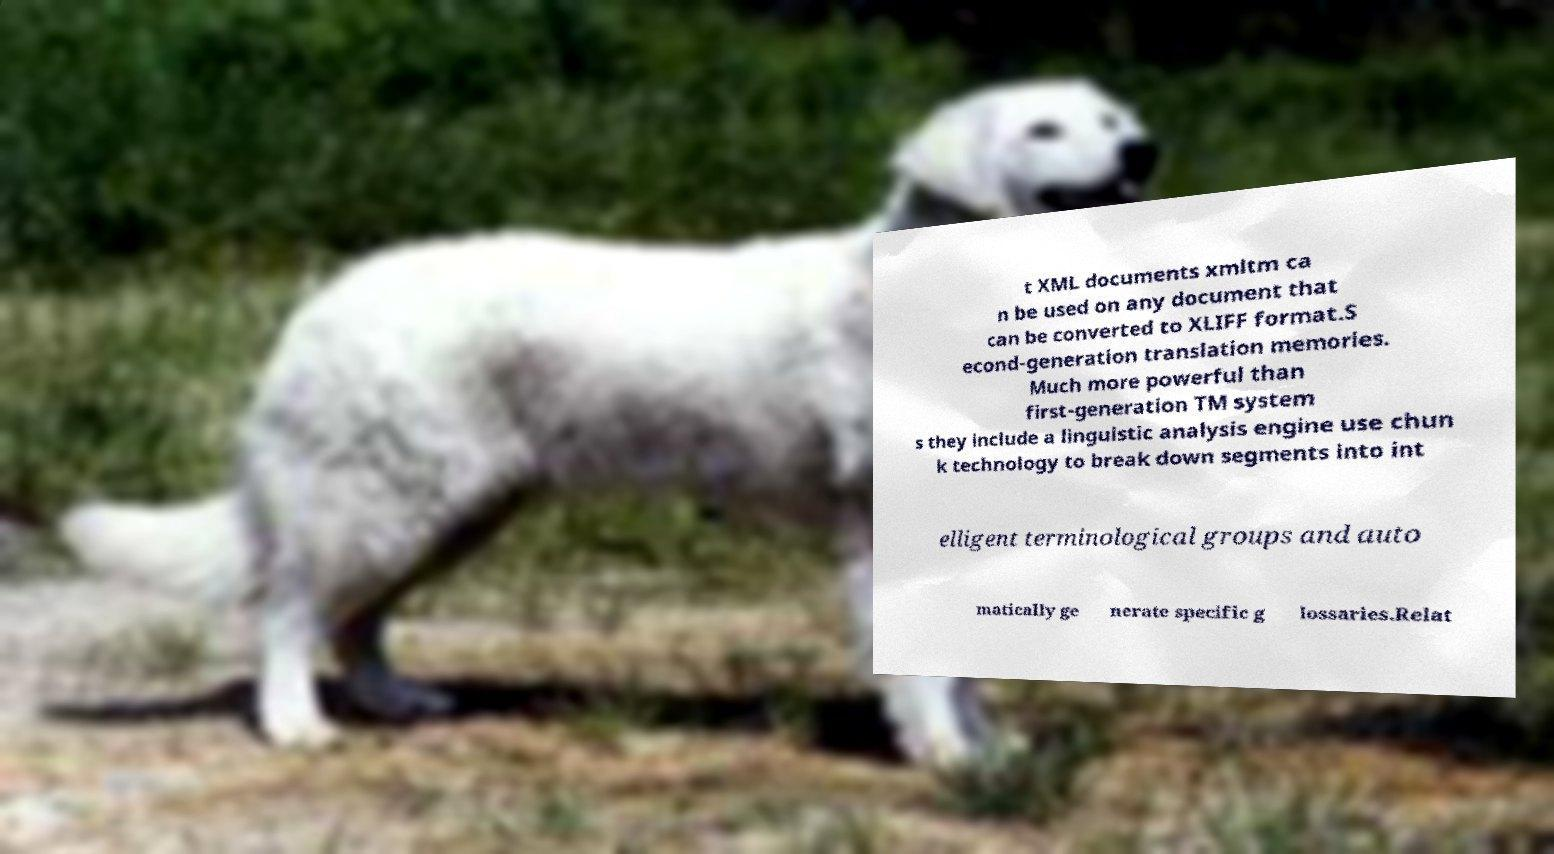Please read and relay the text visible in this image. What does it say? t XML documents xmltm ca n be used on any document that can be converted to XLIFF format.S econd-generation translation memories. Much more powerful than first-generation TM system s they include a linguistic analysis engine use chun k technology to break down segments into int elligent terminological groups and auto matically ge nerate specific g lossaries.Relat 